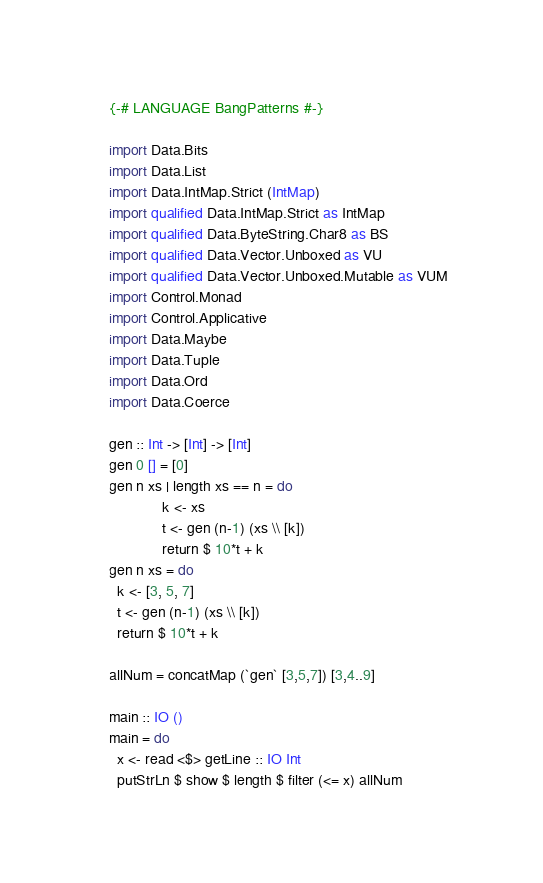Convert code to text. <code><loc_0><loc_0><loc_500><loc_500><_Haskell_>{-# LANGUAGE BangPatterns #-}

import Data.Bits
import Data.List
import Data.IntMap.Strict (IntMap)
import qualified Data.IntMap.Strict as IntMap
import qualified Data.ByteString.Char8 as BS
import qualified Data.Vector.Unboxed as VU
import qualified Data.Vector.Unboxed.Mutable as VUM
import Control.Monad
import Control.Applicative
import Data.Maybe
import Data.Tuple
import Data.Ord
import Data.Coerce

gen :: Int -> [Int] -> [Int]
gen 0 [] = [0]
gen n xs | length xs == n = do
             k <- xs
             t <- gen (n-1) (xs \\ [k])
             return $ 10*t + k
gen n xs = do
  k <- [3, 5, 7]
  t <- gen (n-1) (xs \\ [k])
  return $ 10*t + k

allNum = concatMap (`gen` [3,5,7]) [3,4..9]

main :: IO ()
main = do
  x <- read <$> getLine :: IO Int
  putStrLn $ show $ length $ filter (<= x) allNum</code> 